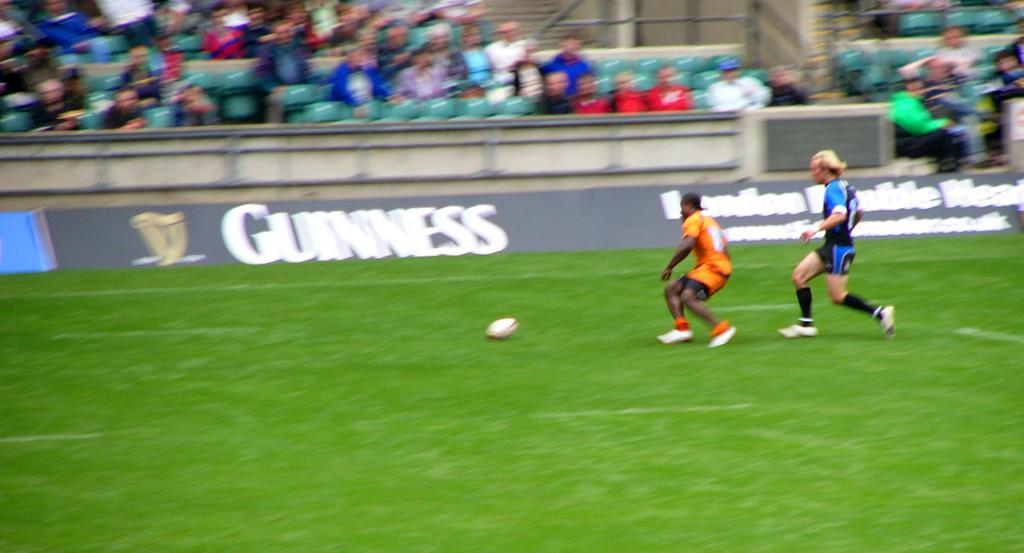Provide a one-sentence caption for the provided image. Two soccer players on the field in front of a Guinness ad. 